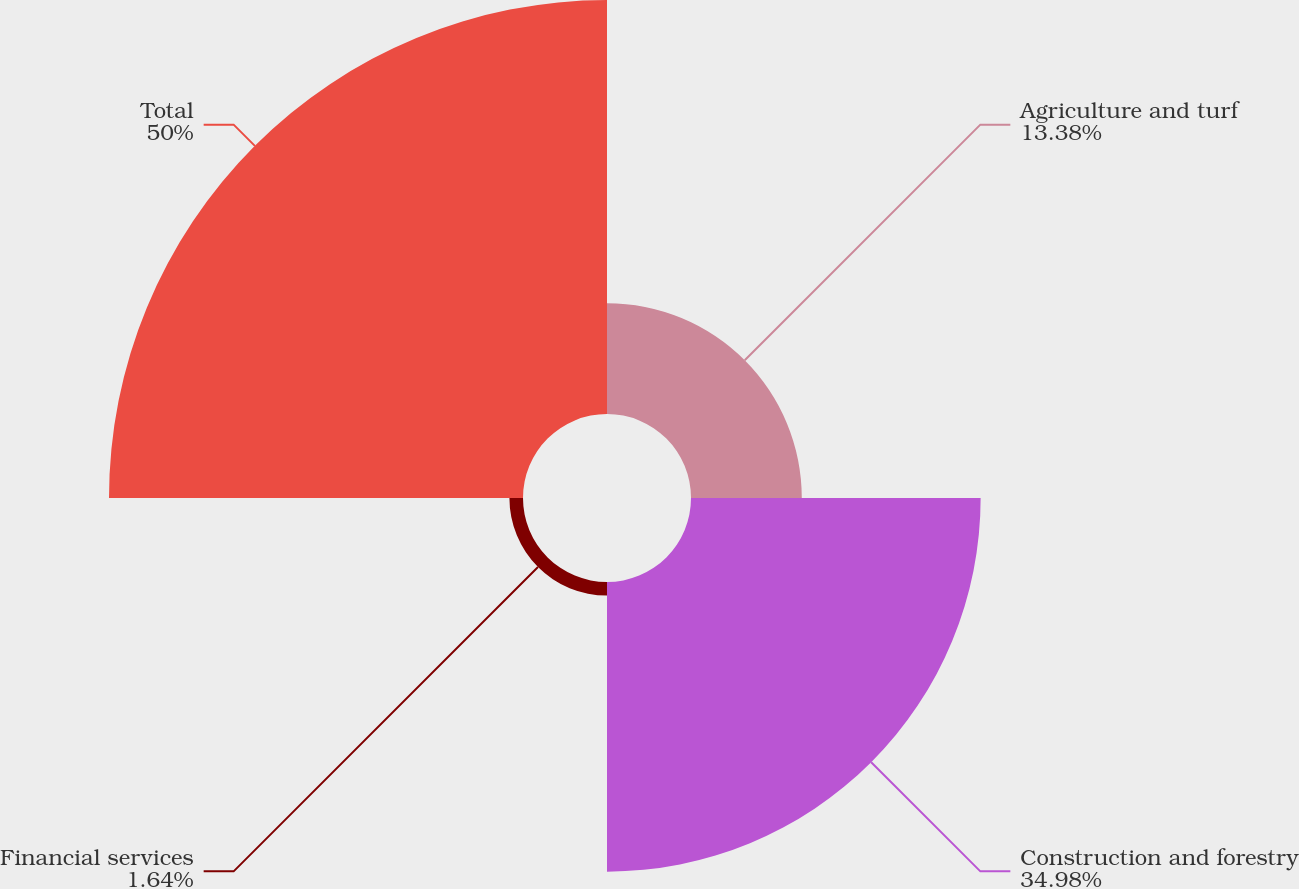Convert chart. <chart><loc_0><loc_0><loc_500><loc_500><pie_chart><fcel>Agriculture and turf<fcel>Construction and forestry<fcel>Financial services<fcel>Total<nl><fcel>13.38%<fcel>34.98%<fcel>1.64%<fcel>50.0%<nl></chart> 